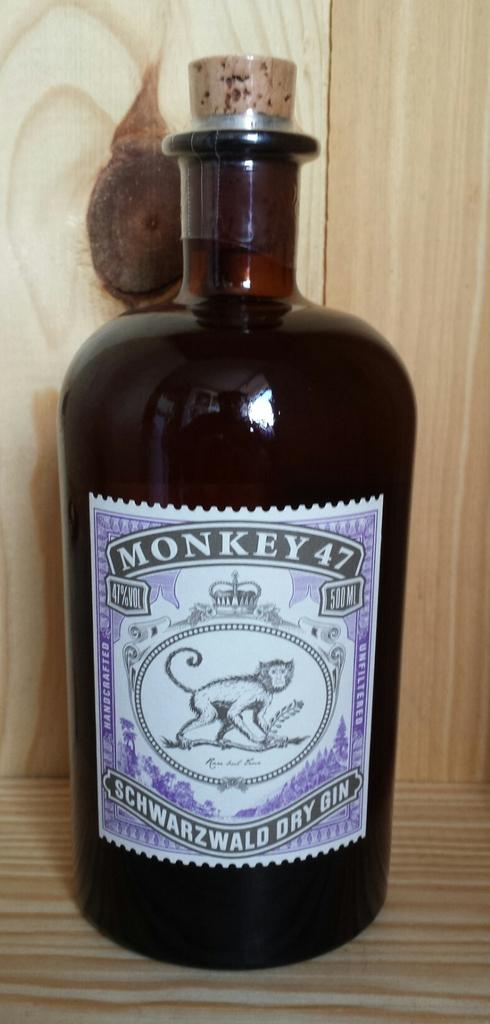Does the bottle contain gin?
Make the answer very short. Yes. What is the name on the bottle?
Your answer should be compact. Monkey 47. 